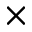<formula> <loc_0><loc_0><loc_500><loc_500>\times</formula> 